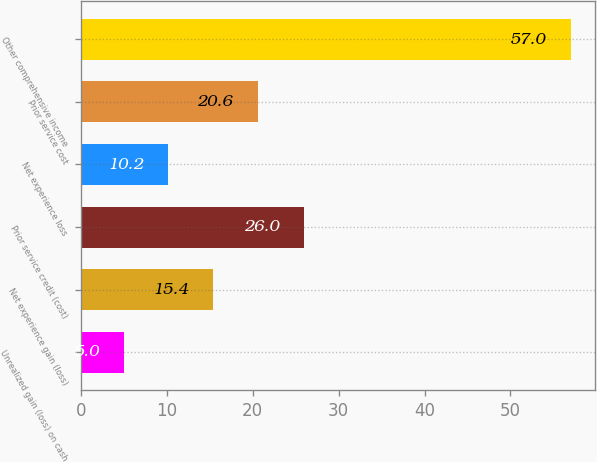Convert chart. <chart><loc_0><loc_0><loc_500><loc_500><bar_chart><fcel>Unrealized gain (loss) on cash<fcel>Net experience gain (loss)<fcel>Prior service credit (cost)<fcel>Net experience loss<fcel>Prior service cost<fcel>Other comprehensive income<nl><fcel>5<fcel>15.4<fcel>26<fcel>10.2<fcel>20.6<fcel>57<nl></chart> 